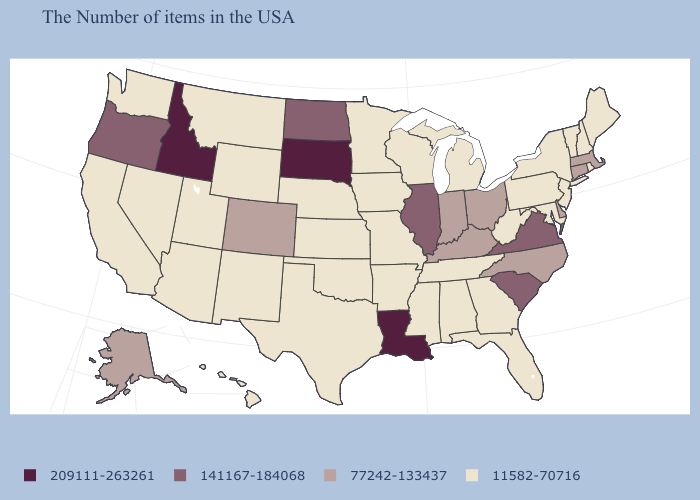What is the highest value in the Northeast ?
Give a very brief answer. 77242-133437. Name the states that have a value in the range 209111-263261?
Quick response, please. Louisiana, South Dakota, Idaho. Does North Dakota have a higher value than Rhode Island?
Concise answer only. Yes. What is the value of New Jersey?
Keep it brief. 11582-70716. How many symbols are there in the legend?
Quick response, please. 4. Name the states that have a value in the range 11582-70716?
Write a very short answer. Maine, Rhode Island, New Hampshire, Vermont, New York, New Jersey, Maryland, Pennsylvania, West Virginia, Florida, Georgia, Michigan, Alabama, Tennessee, Wisconsin, Mississippi, Missouri, Arkansas, Minnesota, Iowa, Kansas, Nebraska, Oklahoma, Texas, Wyoming, New Mexico, Utah, Montana, Arizona, Nevada, California, Washington, Hawaii. What is the value of Tennessee?
Write a very short answer. 11582-70716. What is the value of Utah?
Keep it brief. 11582-70716. Does Texas have the same value as South Dakota?
Answer briefly. No. Among the states that border Indiana , which have the lowest value?
Be succinct. Michigan. Which states have the lowest value in the Northeast?
Concise answer only. Maine, Rhode Island, New Hampshire, Vermont, New York, New Jersey, Pennsylvania. How many symbols are there in the legend?
Give a very brief answer. 4. How many symbols are there in the legend?
Quick response, please. 4. What is the value of New Jersey?
Short answer required. 11582-70716. Name the states that have a value in the range 209111-263261?
Keep it brief. Louisiana, South Dakota, Idaho. 